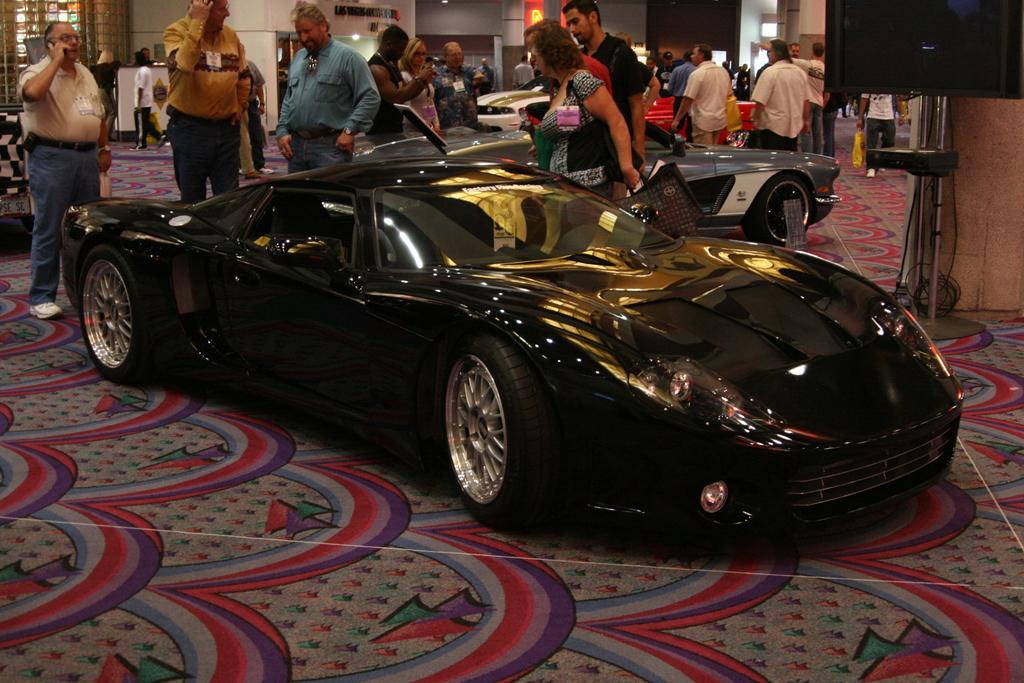Please provide a concise description of this image. Here we can see cars and persons on the floor. There is a carpet on the floor. In the background we can see a wall, pillar, and lights. Here we can see a screen. 